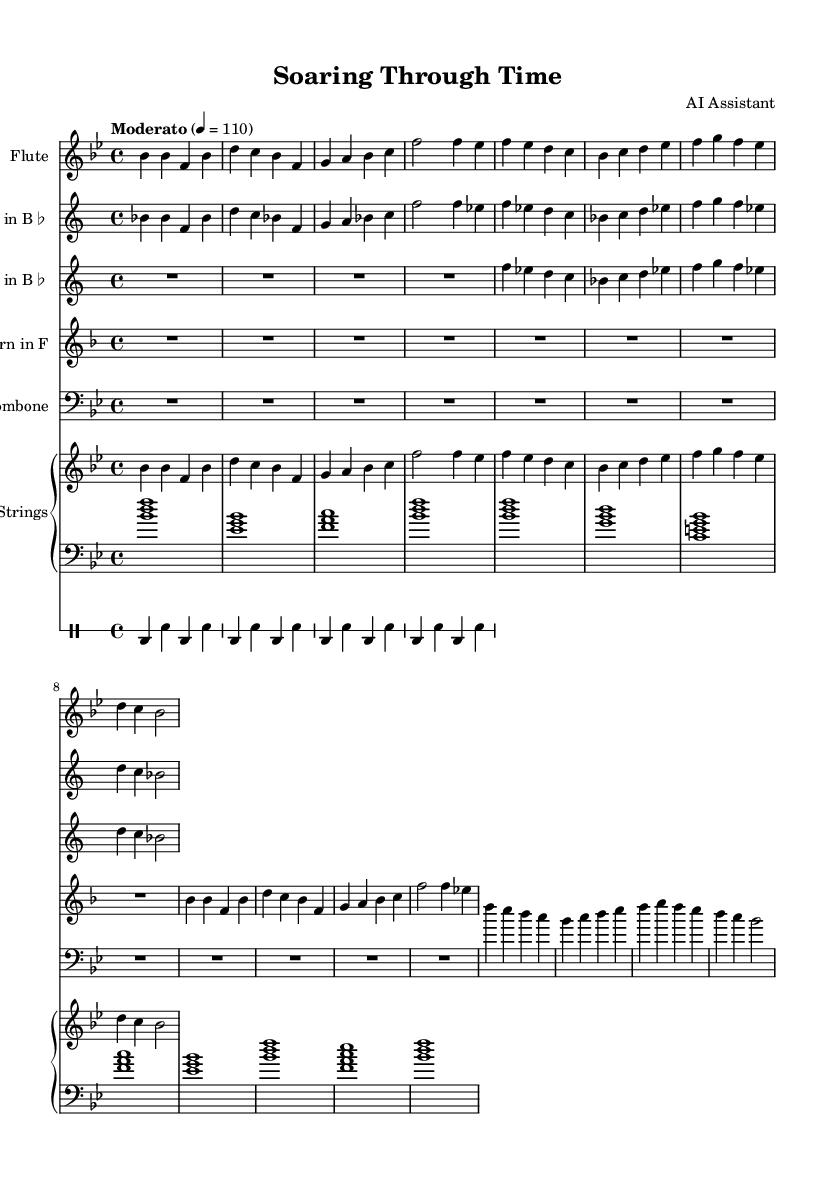What is the key signature of this music? The key signature has two flats, indicating B flat major.
Answer: B flat major What is the time signature? The time signature shown is 4/4, meaning there are four beats in each measure.
Answer: 4/4 What is the tempo marking? The tempo marking indicates a moderate pace set at 110 beats per minute, which is denoted as "Moderato" with a metronome marking.
Answer: Moderato 4 = 110 Which instrument plays the main theme first? The flute staff is the first instrument to present the main theme, as shown at the beginning of the score.
Answer: Flute How many measures are in the main theme A section? The main theme A section consists of four measures, visibly grouped in the score.
Answer: 4 What type of composition is this? This composition is orchestral and focuses on patriotic themes, reflecting military aviation history, indicated by both its title and orchestration.
Answer: Patriotic orchestral 